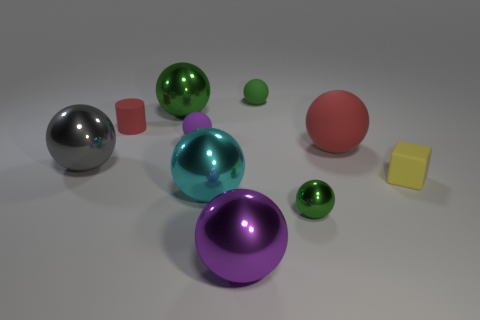Is there a yellow metal cylinder of the same size as the yellow cube?
Provide a succinct answer. No. What size is the rubber cylinder that is the same color as the big matte object?
Give a very brief answer. Small. What is the material of the sphere that is on the left side of the cylinder?
Keep it short and to the point. Metal. Is the number of big matte objects behind the big green metallic ball the same as the number of large green metal spheres that are to the right of the tiny shiny ball?
Offer a terse response. Yes. Does the green metal sphere behind the tiny yellow block have the same size as the purple object in front of the matte cube?
Offer a very short reply. Yes. How many rubber cylinders are the same color as the large rubber sphere?
Keep it short and to the point. 1. There is a big sphere that is the same color as the tiny metallic sphere; what is it made of?
Offer a terse response. Metal. Is the number of large gray spheres that are right of the tiny cube greater than the number of big purple blocks?
Offer a very short reply. No. Does the yellow rubber thing have the same shape as the large red matte thing?
Provide a short and direct response. No. What number of cyan objects are made of the same material as the small yellow thing?
Provide a succinct answer. 0. 